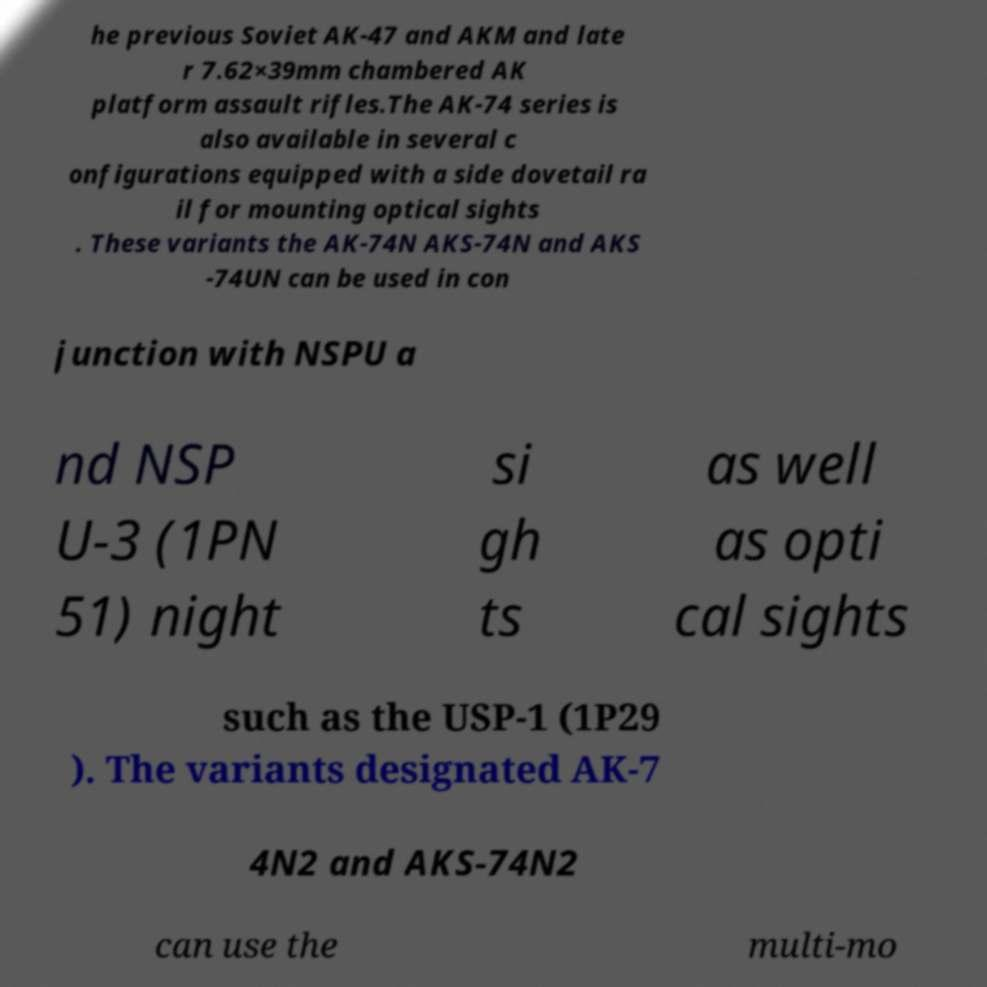Could you extract and type out the text from this image? he previous Soviet AK-47 and AKM and late r 7.62×39mm chambered AK platform assault rifles.The AK-74 series is also available in several c onfigurations equipped with a side dovetail ra il for mounting optical sights . These variants the AK-74N AKS-74N and AKS -74UN can be used in con junction with NSPU a nd NSP U-3 (1PN 51) night si gh ts as well as opti cal sights such as the USP-1 (1P29 ). The variants designated AK-7 4N2 and AKS-74N2 can use the multi-mo 